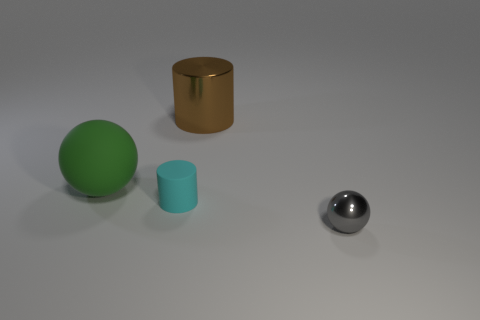Looking at their positions, can you infer any specific pattern or arrangement? The objects seem to be arranged with no particular pattern in mind. They are spaced unevenly across a flat surface with the two spheres on opposite sides. If looking for symmetry or a specific sequence in their placement, there doesn't seem to be any. It appears to be a random placement for display or examination. 